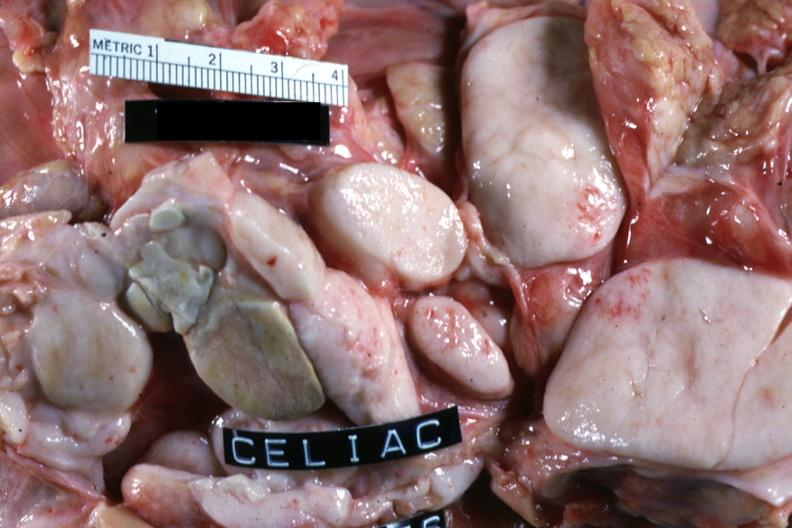s syndactyly present?
Answer the question using a single word or phrase. No 